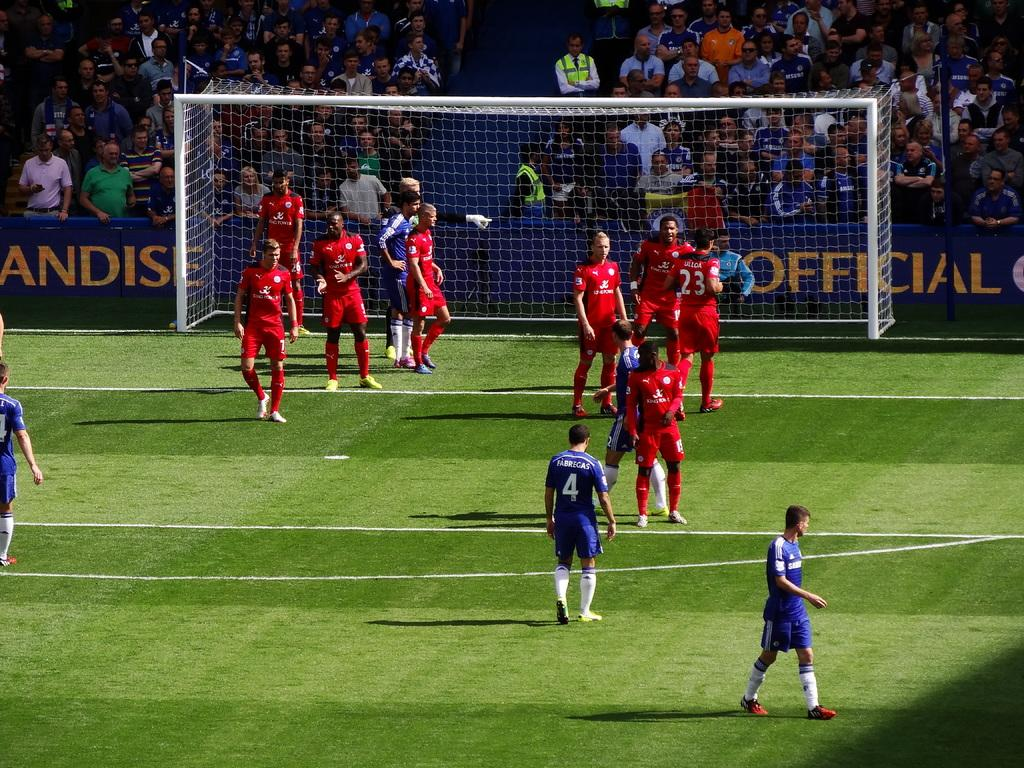What is happening in the image involving the people on the ground? There are many people on the ground in the image, but the specific activity cannot be determined from the provided facts. What can be seen in the background of the image? There is a goal post and many people visible in the background of the image. What is the purpose of the banner in the image? The purpose of the banner in the image cannot be determined from the provided facts. What type of cake is being served to the people near the zipper in the image? There is no cake or zipper present in the image. How many oranges are visible on the banner in the image? There are no oranges visible on the banner in the image. 